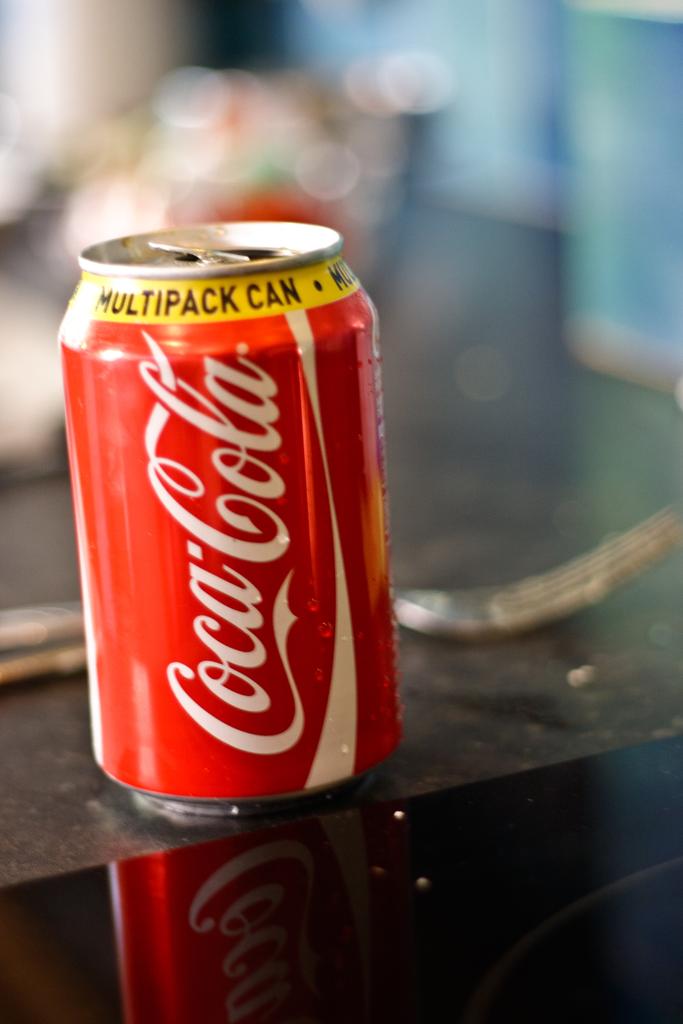Is this a can of coke?
Offer a very short reply. Yes. What kind of can is this?
Your answer should be compact. Coca-cola. 